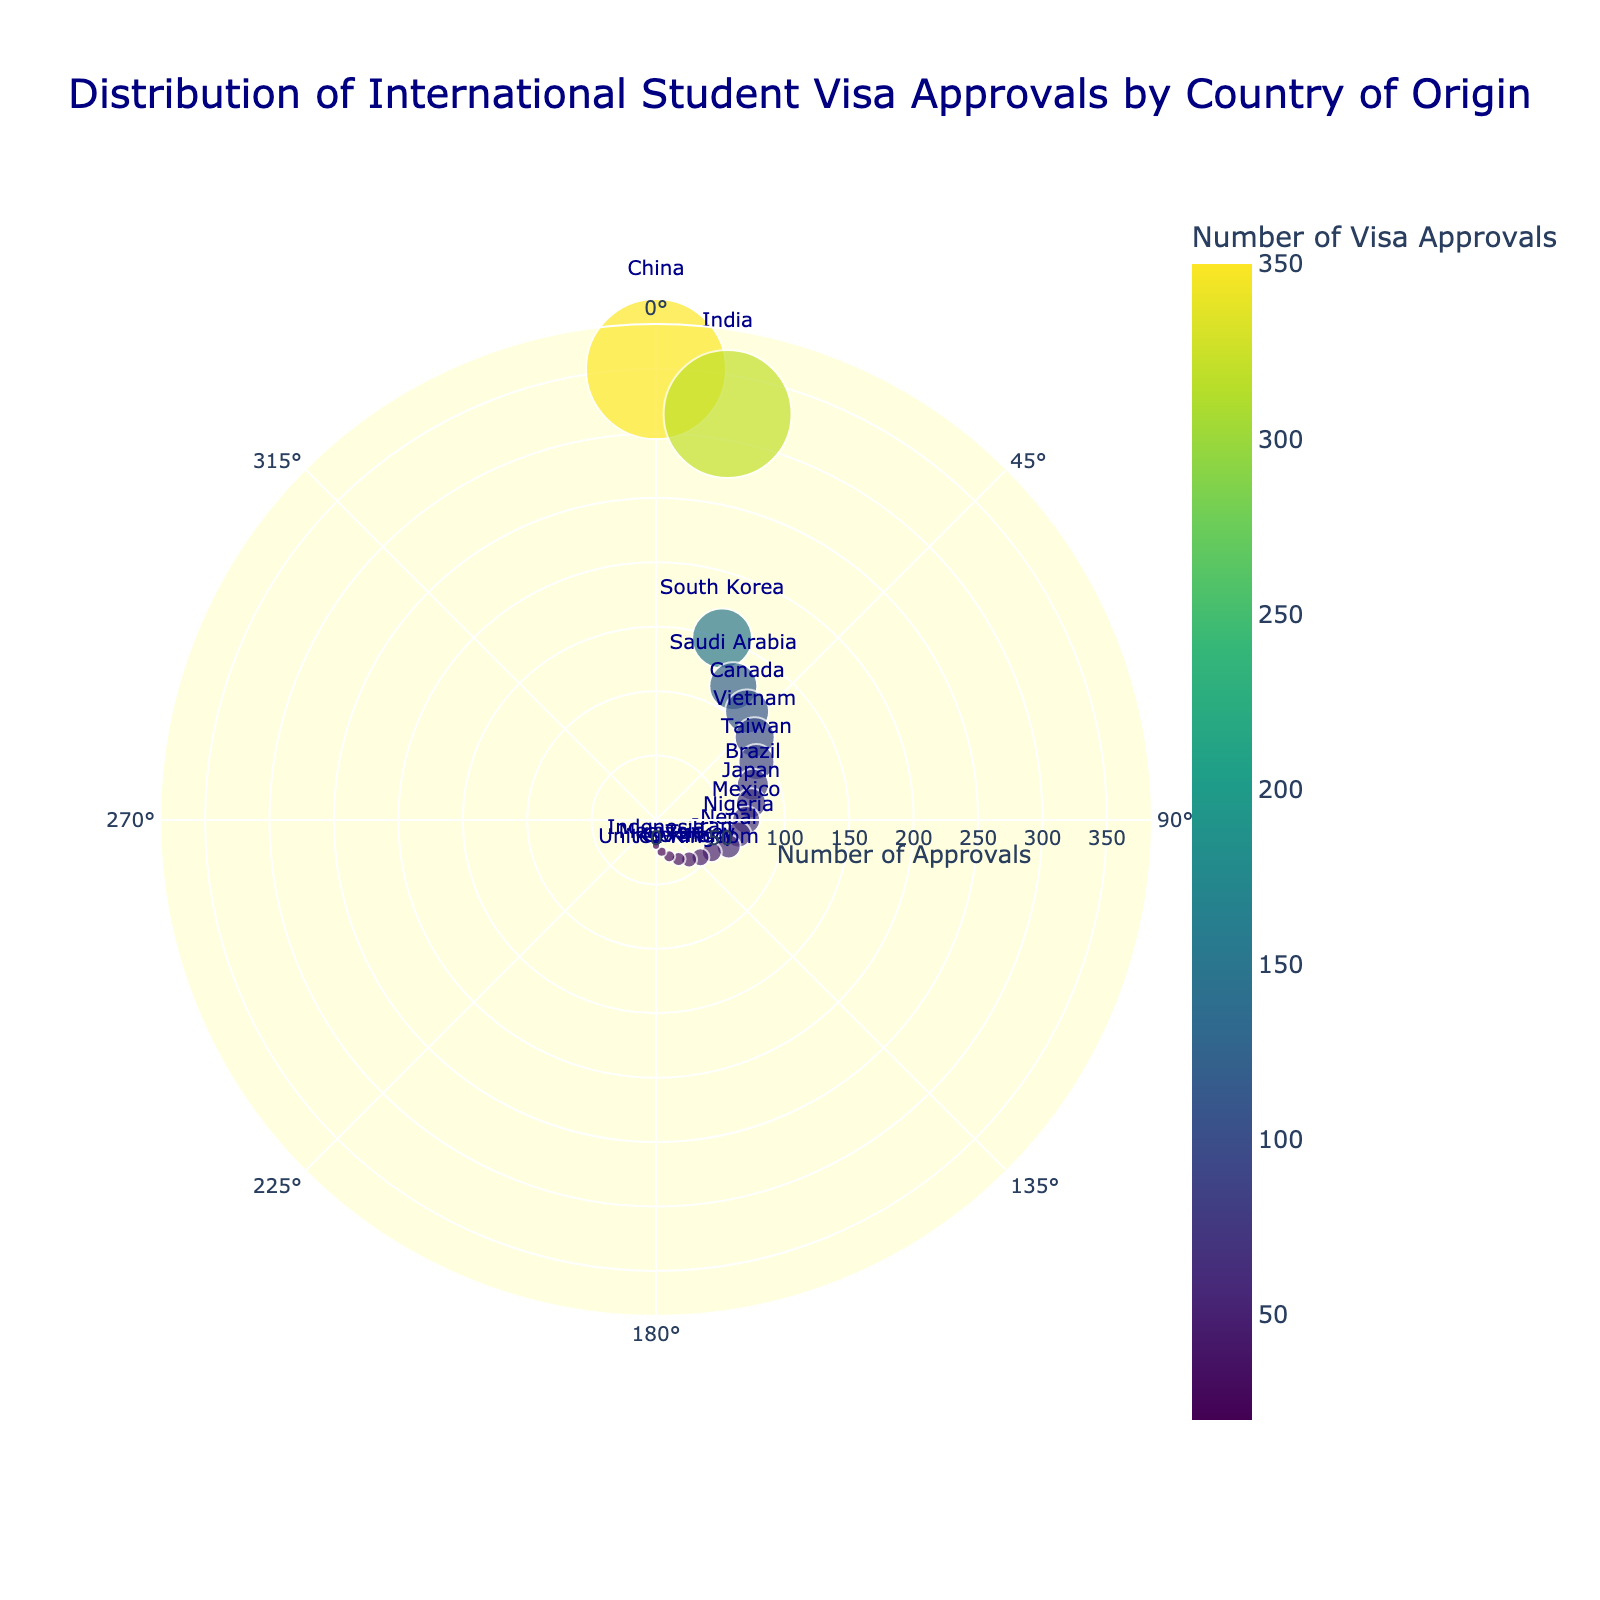What is the title of the chart? The title is located at the top center of the chart and it describes the main topic the chart is depicting.
Answer: Distribution of International Student Visa Approvals by Country of Origin Which country has the highest number of visa approvals? The country with the highest number of visa approvals will have the largest radius in the chart.
Answer: China What is the lowest number of visa approvals shown in the chart? The smallest radius in the chart corresponds to the lowest number of visa approvals.
Answer: 20 How many countries have more than 100 visa approvals? By inspecting the radii in the chart, we identify the countries with radii greater than 100.
Answer: 6 Which country is located at an angle of 90 degrees? The text label located at the 90-degree angle on the chart represents the country there.
Answer: Mexico Which two countries have the closest number of visa approvals to each other? Finding countries with radii that are numerically close together will find the closest numbers of visa approvals.
Answer: Mexico and Nigeria What's the difference in visa approvals between China and India? Subtract the number of visa approvals for India from that for China: 350 - 320.
Answer: 30 Which country is positioned at 180 degrees and how many approvals does it have? Identify the country label and radius on the far right (180-degree mark) of the chart.
Answer: Indonesia, 20 How are the sizes of the markers related to the number of visa approvals? The size of each marker in the chart scales with the radius, which represents the number of visa approvals. Larger numbers have larger markers.
Answer: They reflect the number of visa approvals What color range is used to represent visa approvals? By observing the color gradient in the chart legend, understand that darker colors represent higher numbers of approvals and lighter colors represent fewer.
Answer: Viridis colorscale ranging from dark blue to light yellow 